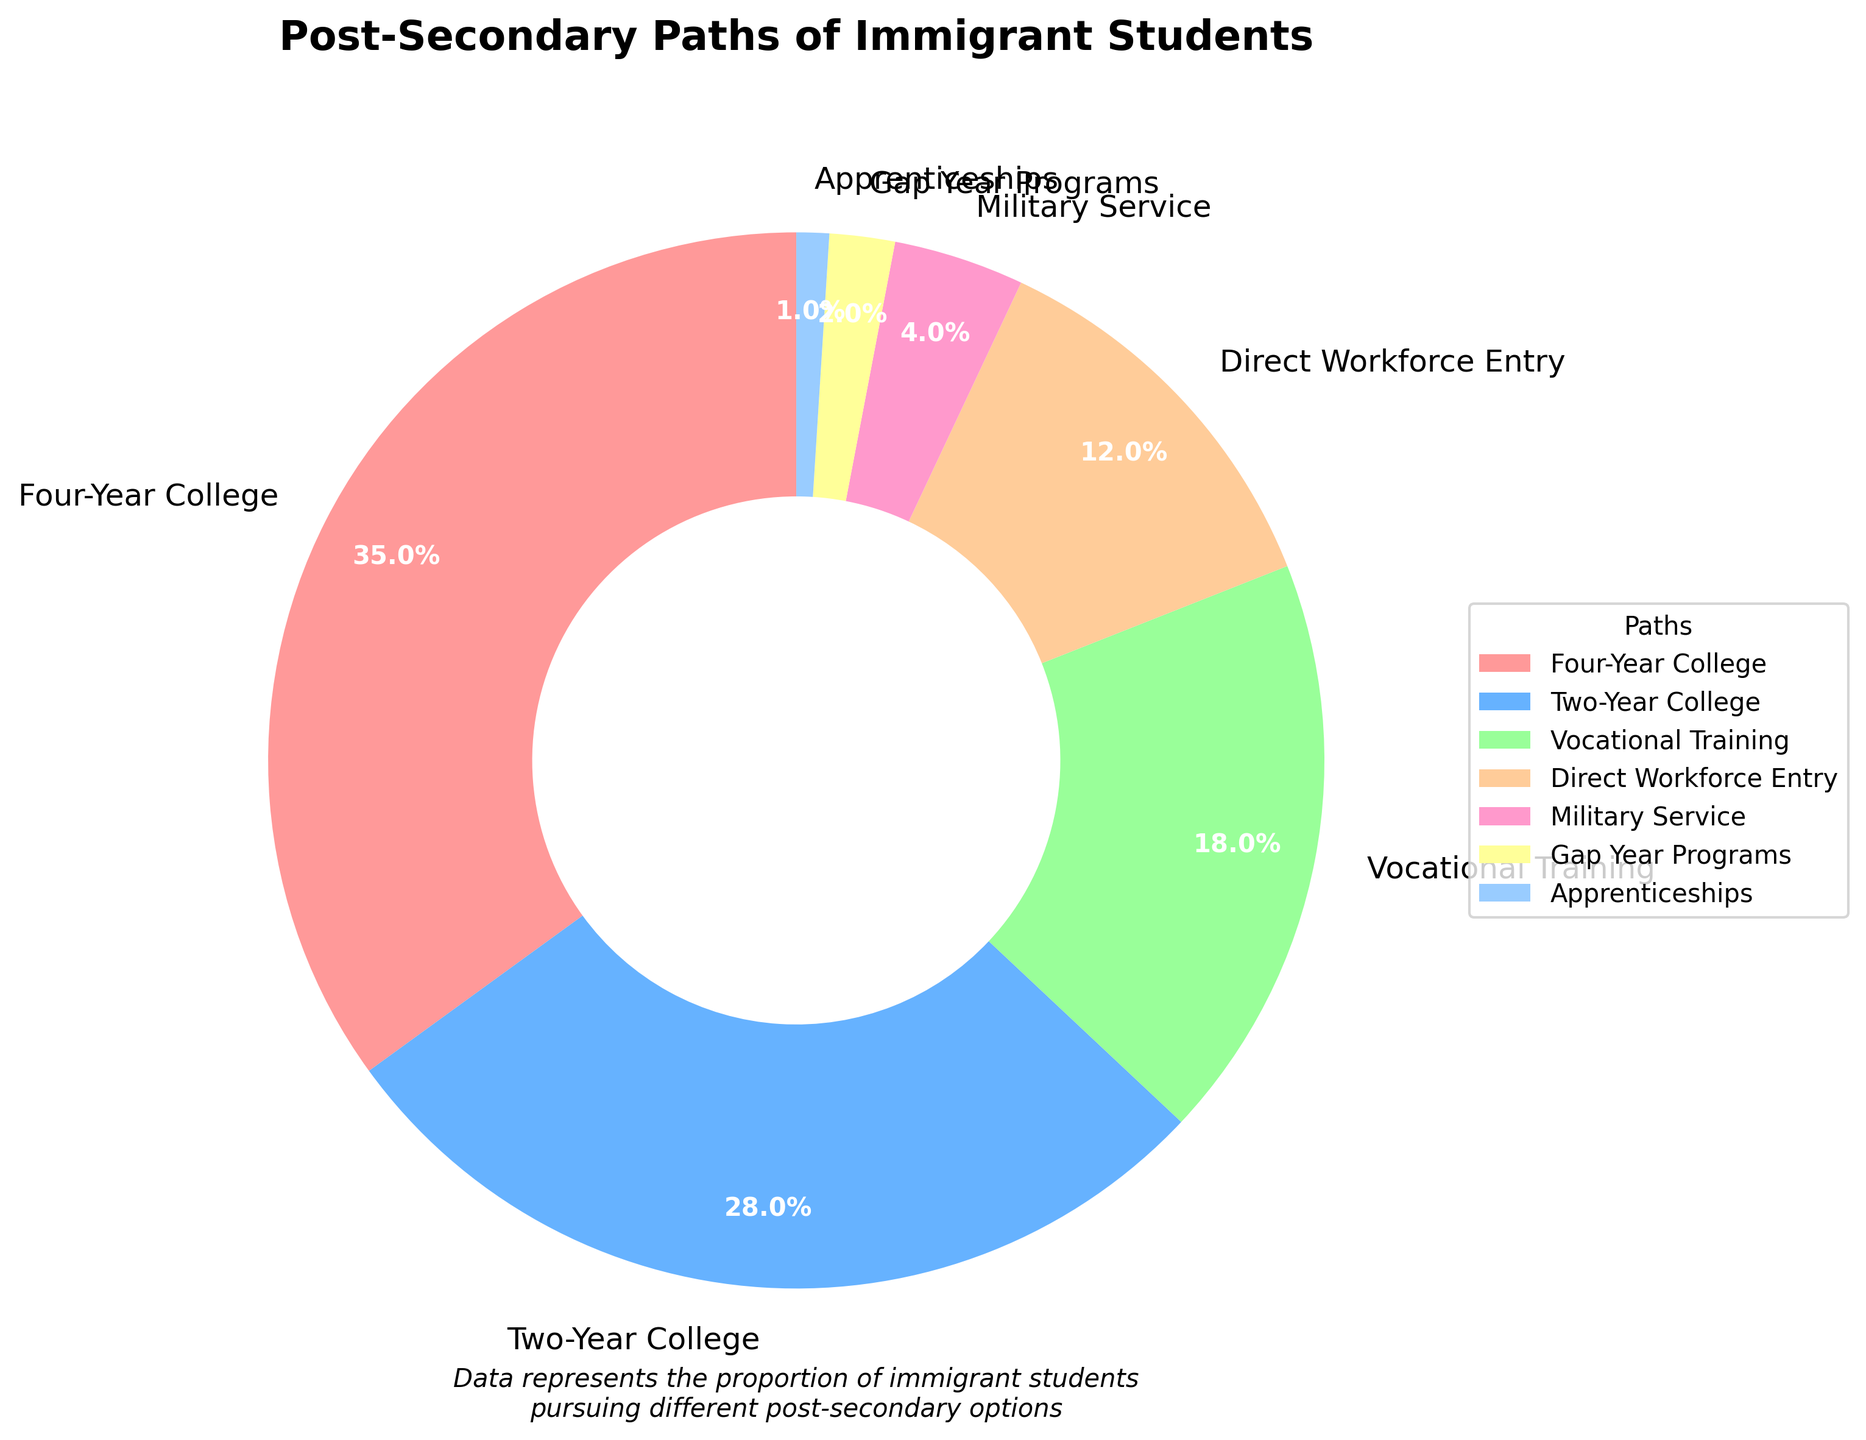Which post-secondary path has the highest proportion of immigrant students? The pie chart segments the paths, and the 'Four-Year College' portion is the largest, represented by 35%.
Answer: Four-Year College What is the combined percentage of immigrant students pursuing either vocational training or direct workforce entry? To find the combined percentage, add the percentages for 'Vocational Training' and 'Direct Workforce Entry'. This is 18% + 12% = 30%.
Answer: 30% Which pathway has a greater percentage of immigrant students, gap year programs or military service? Compare the percentages given for 'Gap Year Programs' and 'Military Service', which are 2% and 4% respectively. 4% is greater than 2%.
Answer: Military Service How much larger is the percentage of students attending vocational training compared to those taking a gap year? Subtract the percentage of 'Gap Year Programs' from 'Vocational Training'. This is 18% - 2% = 16%.
Answer: 16% Rank the post-secondary paths from the largest percentage of students to the smallest. Arrange the provided percentages in descending order: Four-Year College (35%), Two-Year College (28%), Vocational Training (18%), Direct Workforce Entry (12%), Military Service (4%), Gap Year Programs (2%), Apprenticeships (1%).
Answer: Four-Year College, Two-Year College, Vocational Training, Direct Workforce Entry, Military Service, Gap Year Programs, Apprenticeships What percentage of immigrant students pursue educational paths (college and vocational training) compared to non-educational paths (workforce, military, gap year, apprenticeships)? Sum the educational paths (35% + 28% + 18%) = 81% and non-educational paths (12% + 4% + 2% + 1%) = 19%.
Answer: 81% for educational, 19% for non-educational Which segment in the chart is represented by a pink color? The segments are colored and labeled. The pink color represents the 'Four-Year College' segment.
Answer: Four-Year College Is the percentage of students entering the military service and those in apprenticeships combined greater than those in a gap year program? Add the percentages for 'Military Service' and 'Apprenticeships' (4% + 1%) = 5%. Compare this to 'Gap Year Programs' which is 2%. Since 5% is greater than 2%, the combined percentage is larger.
Answer: Yes 